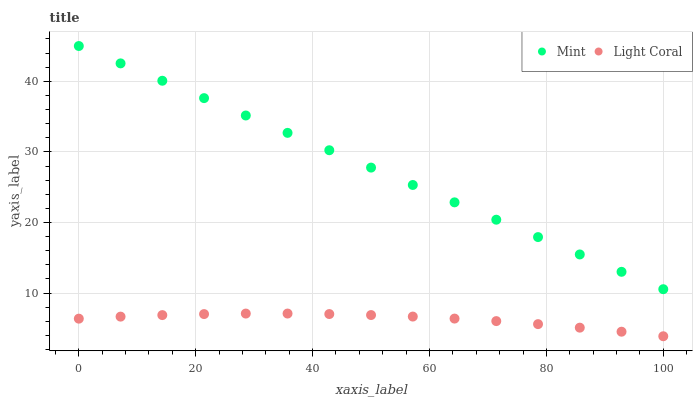Does Light Coral have the minimum area under the curve?
Answer yes or no. Yes. Does Mint have the maximum area under the curve?
Answer yes or no. Yes. Does Mint have the minimum area under the curve?
Answer yes or no. No. Is Mint the smoothest?
Answer yes or no. Yes. Is Light Coral the roughest?
Answer yes or no. Yes. Is Mint the roughest?
Answer yes or no. No. Does Light Coral have the lowest value?
Answer yes or no. Yes. Does Mint have the lowest value?
Answer yes or no. No. Does Mint have the highest value?
Answer yes or no. Yes. Is Light Coral less than Mint?
Answer yes or no. Yes. Is Mint greater than Light Coral?
Answer yes or no. Yes. Does Light Coral intersect Mint?
Answer yes or no. No. 